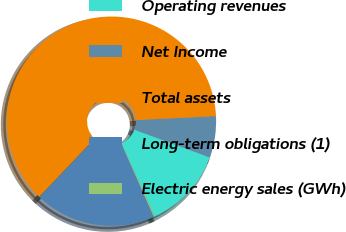Convert chart to OTSL. <chart><loc_0><loc_0><loc_500><loc_500><pie_chart><fcel>Operating revenues<fcel>Net Income<fcel>Total assets<fcel>Long-term obligations (1)<fcel>Electric energy sales (GWh)<nl><fcel>12.57%<fcel>6.38%<fcel>62.11%<fcel>18.76%<fcel>0.18%<nl></chart> 